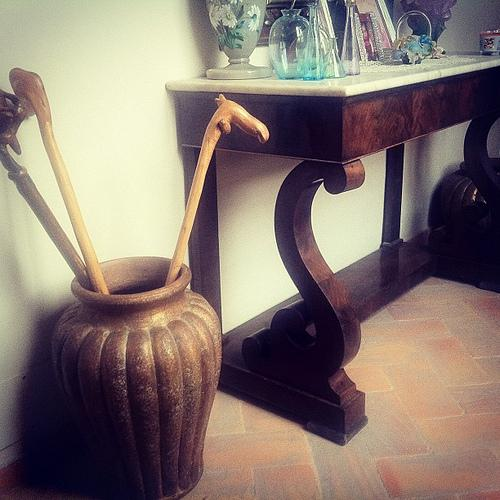Question: what color is the bottom of the table?
Choices:
A. Brown.
B. Teal.
C. Purple.
D. Neon.
Answer with the letter. Answer: A Question: how many flower vases are in this photo?
Choices:
A. 12.
B. 13.
C. 5.
D. 1.
Answer with the letter. Answer: D Question: where is the glass flower vase?
Choices:
A. Bedside.
B. On the table.
C. At the store.
D. In a box.
Answer with the letter. Answer: B 